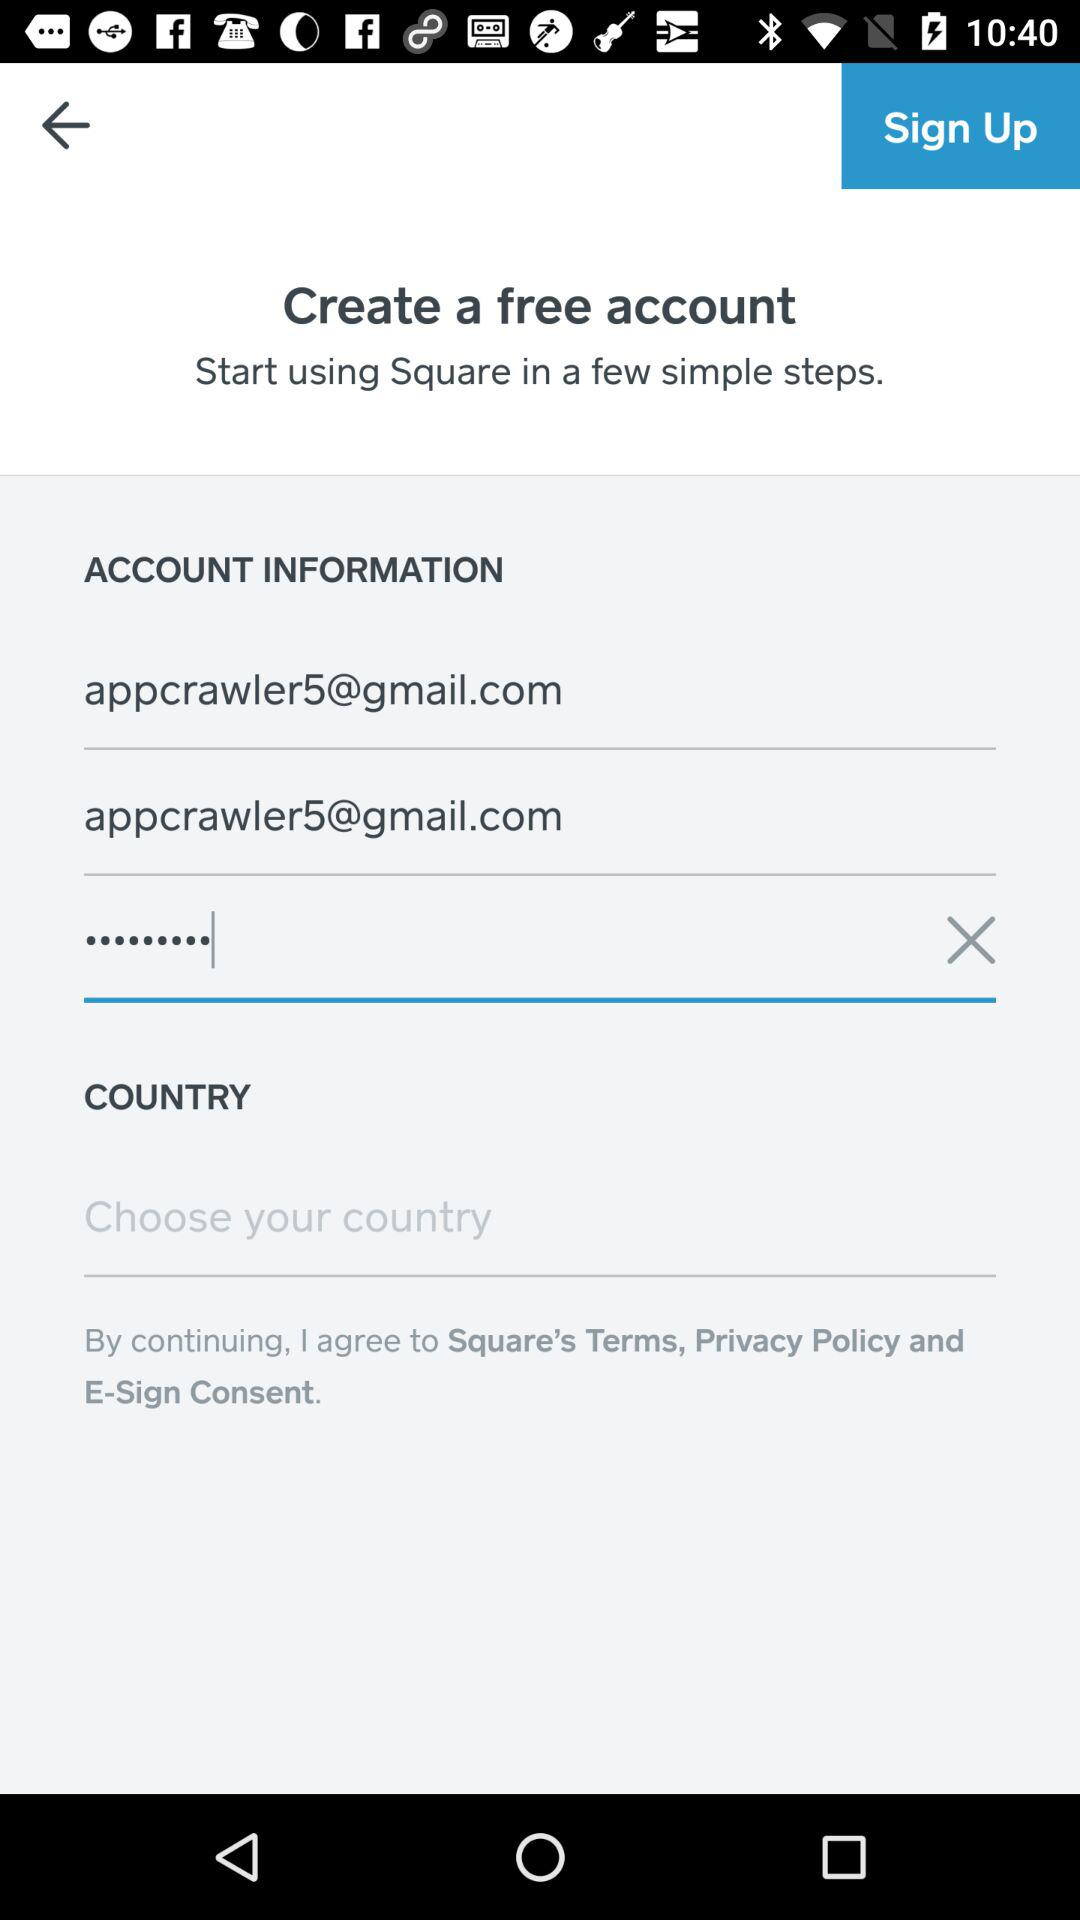What are the possible reasons for blurring out certain details in this image? Details in images are typically blurred to protect sensitive information such as personal email addresses, passwords, or to comply with privacy regulations. 